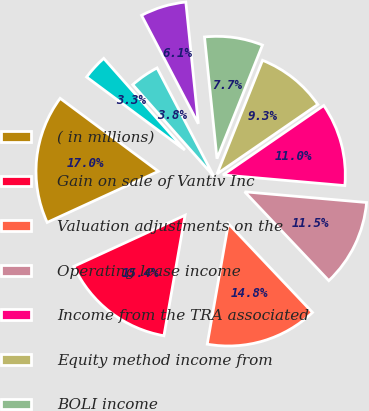Convert chart. <chart><loc_0><loc_0><loc_500><loc_500><pie_chart><fcel>( in millions)<fcel>Gain on sale of Vantiv Inc<fcel>Valuation adjustments on the<fcel>Operating lease income<fcel>Income from the TRA associated<fcel>Equity method income from<fcel>BOLI income<fcel>Cardholder fees<fcel>Private equity investment<fcel>Consumer loan and lease fees<nl><fcel>17.03%<fcel>15.38%<fcel>14.83%<fcel>11.54%<fcel>10.99%<fcel>9.34%<fcel>7.69%<fcel>6.05%<fcel>3.85%<fcel>3.3%<nl></chart> 